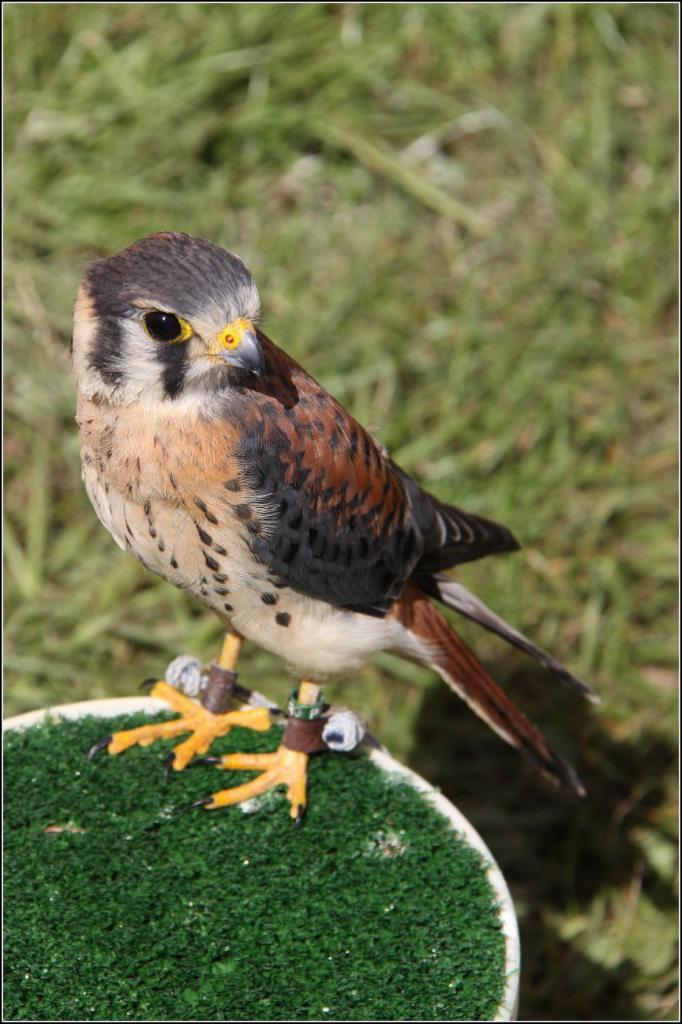What type of animal can be seen in the image? There is a bird in the image. What is the bird standing on? The bird is standing on a green surface. What type of vegetation is present on the ground in the image? There are grasses on the ground in the image. Is there a tent in the image? No, there is no tent present in the image. What shape is the bird in the image? The shape of the bird cannot be determined from the image alone, as it is a two-dimensional representation. 